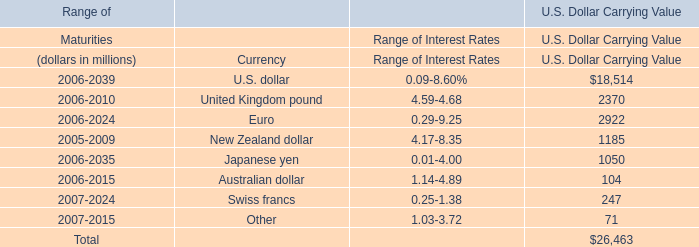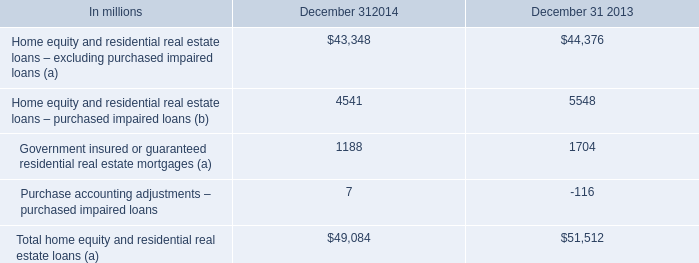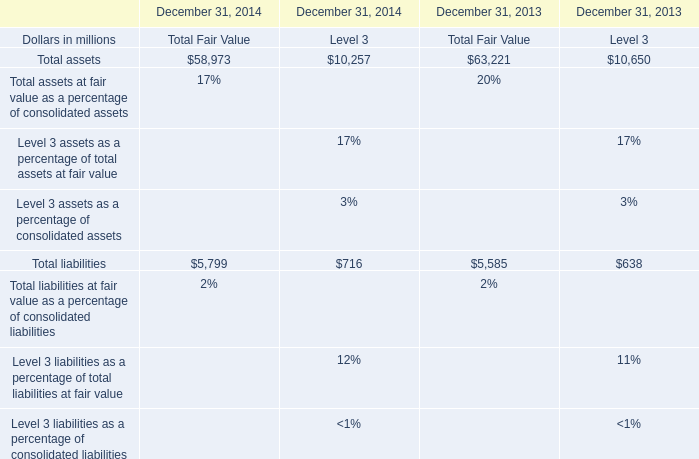what percentage of the total home equity and real estate loans in 2014 explicitly excluded purchased impaired loans? 
Computations: (43348 / 49084)
Answer: 0.88314. 